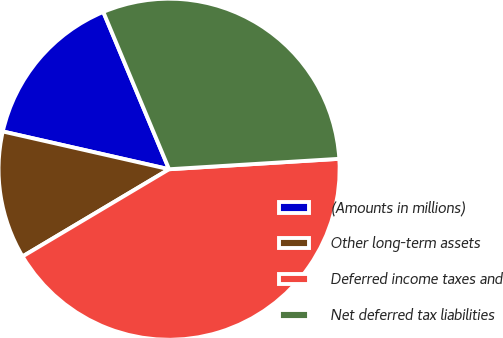Convert chart. <chart><loc_0><loc_0><loc_500><loc_500><pie_chart><fcel>(Amounts in millions)<fcel>Other long-term assets<fcel>Deferred income taxes and<fcel>Net deferred tax liabilities<nl><fcel>15.14%<fcel>12.1%<fcel>42.43%<fcel>30.33%<nl></chart> 